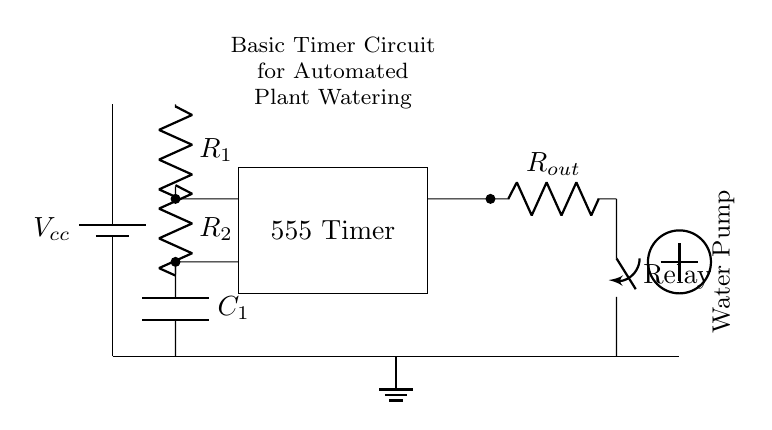What is the purpose of the 555 Timer in this circuit? The 555 Timer is used to generate timed output pulses, which control the operation of the water pump at specified intervals.
Answer: Timed output What components are used in the timing circuit? The timing circuit consists of two resistors (R1 and R2) and one capacitor (C1), which together determine the cycle time of the timer.
Answer: Resistors and capacitor How many outputs does the 555 Timer have in this circuit? The 555 Timer has one output used to control the relay, which activates the water pump.
Answer: One What type of switch is shown in the circuit? The circuit includes a relay switch, which is used to control the flow of power to the water pump upon receiving a signal from the timer.
Answer: Relay switch Which component is responsible for starting and stopping the water pump? The relay component activates and deactivates the water pump based on the output from the 555 Timer, controlling its operation.
Answer: Relay What is the configuration of the water pump in the circuit? The water pump is shown as a load symbol connected to the relay switch, indicating it is activated when the relay is closed.
Answer: Load symbol 